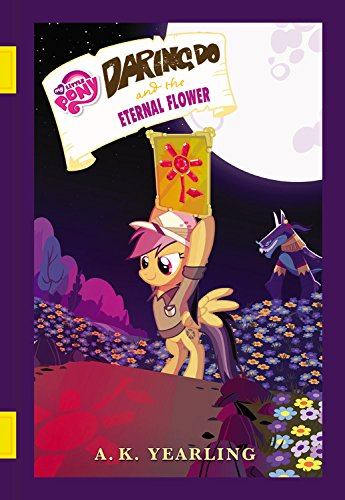What can you deduce about the setting of the story from the cover image? The cover art suggests a story set in a vibrant, natural environment filled with flowers and mystical elements. The presence of the nighttime sky and stars also hints at an element of magic or fantasy within the book's setting. Is there an antagonist character shown on this cover? Yes, there appears to be an antagonist in the background. The shadowy figure with glowing eyes looming behind Daring Do suggests a mysterious adversary who may be involved in the plot. 